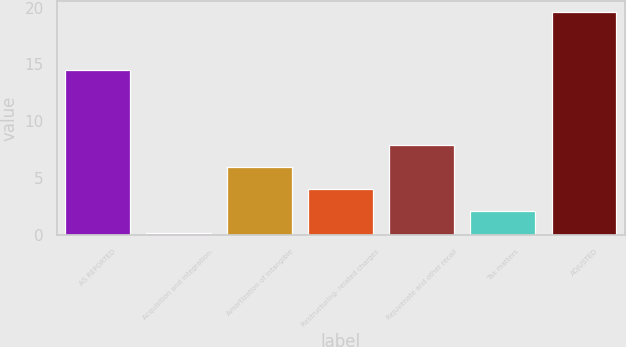Convert chart to OTSL. <chart><loc_0><loc_0><loc_500><loc_500><bar_chart><fcel>AS REPORTED<fcel>Acquisition and integration-<fcel>Amortization of intangible<fcel>Restructuring- related charges<fcel>Rejuvenate and other recall<fcel>Tax matters<fcel>ADJUSTED<nl><fcel>14.5<fcel>0.2<fcel>6.02<fcel>4.08<fcel>7.96<fcel>2.14<fcel>19.6<nl></chart> 